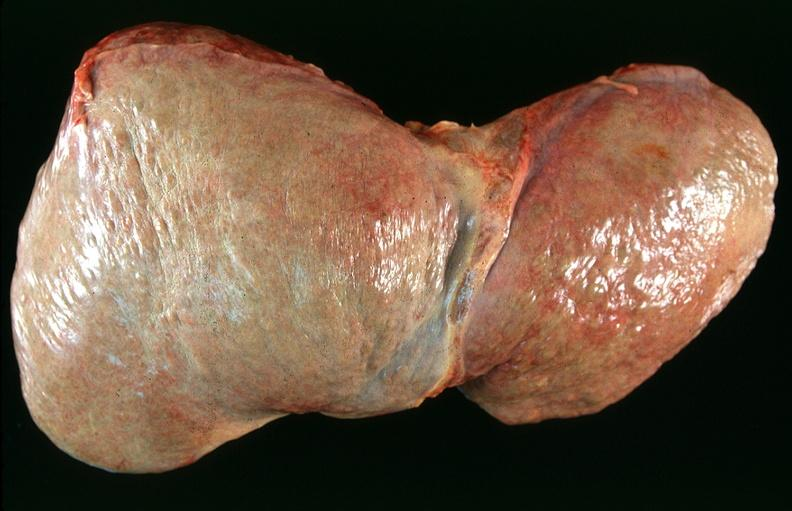s this typical lesion present?
Answer the question using a single word or phrase. No 